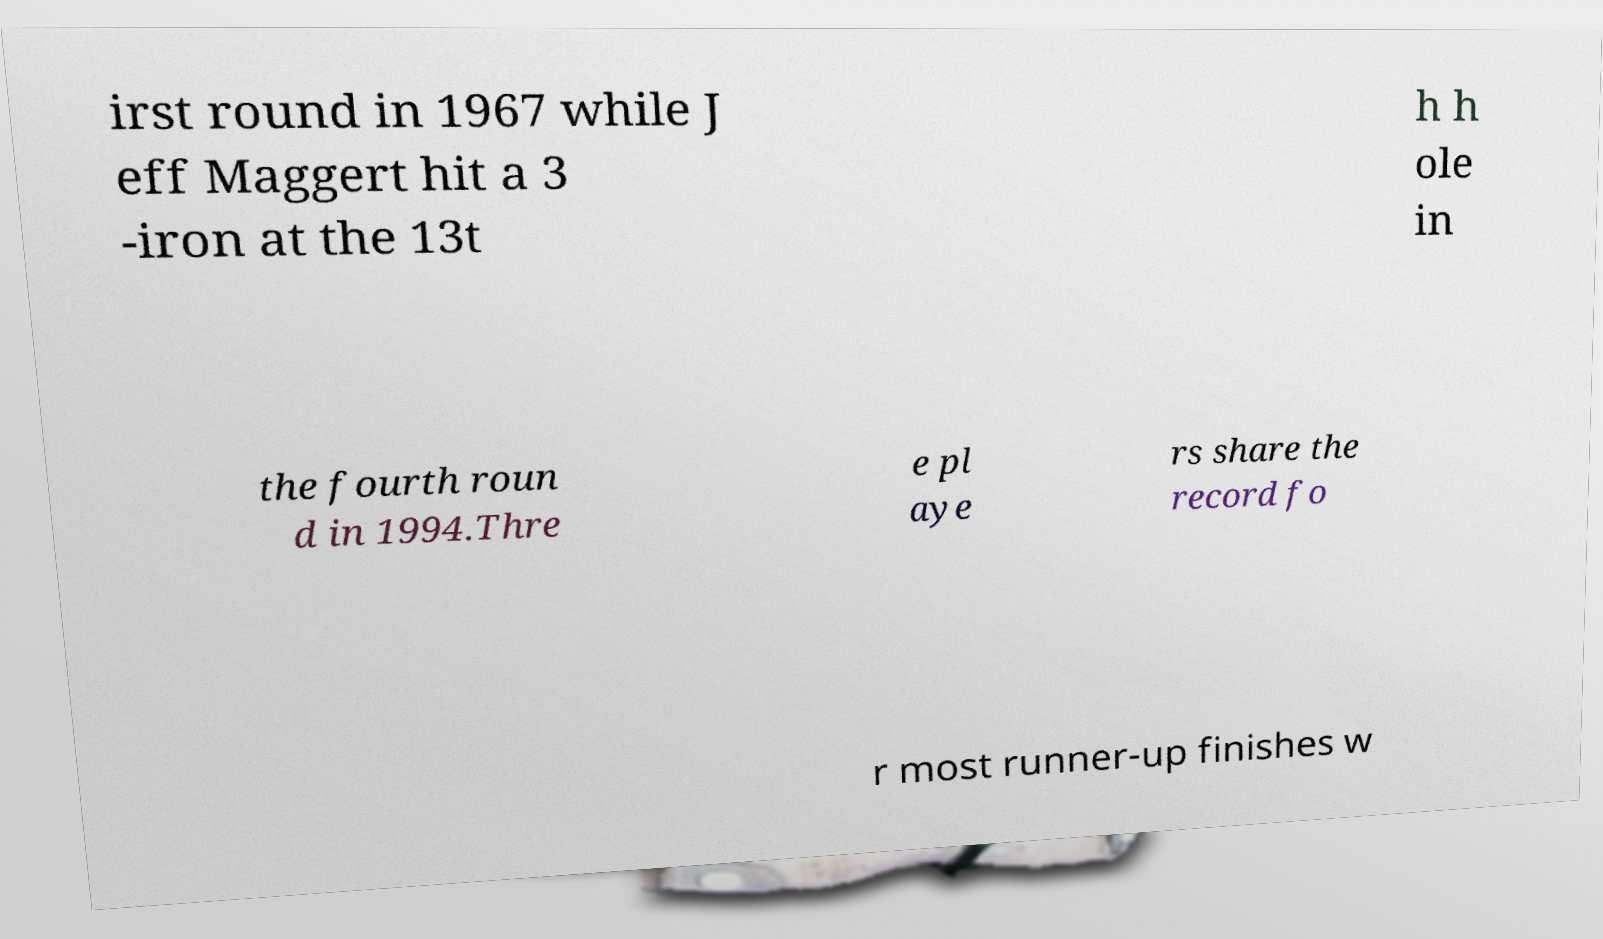I need the written content from this picture converted into text. Can you do that? irst round in 1967 while J eff Maggert hit a 3 -iron at the 13t h h ole in the fourth roun d in 1994.Thre e pl aye rs share the record fo r most runner-up finishes w 